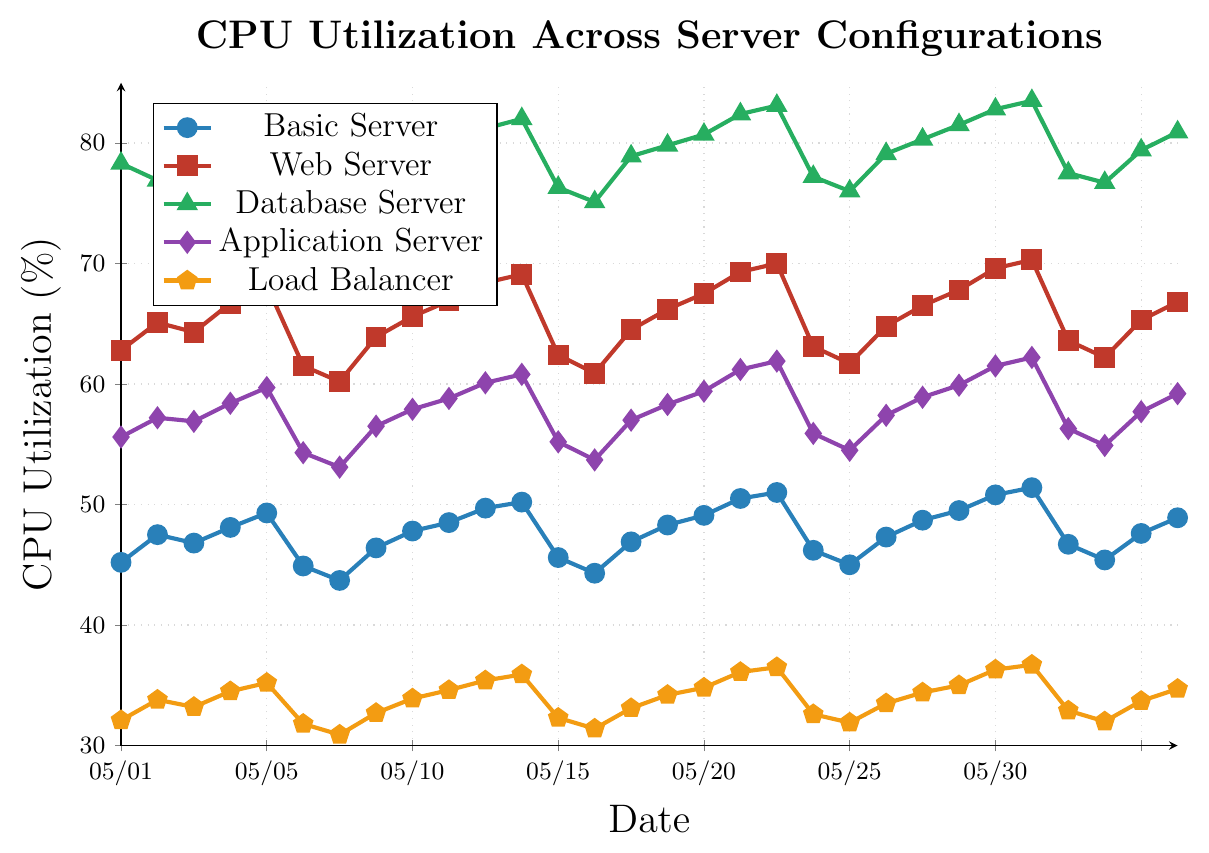How does the CPU utilization of the Web Server compare to the Basic Server on May 12? By examining the points corresponding to May 12 for both lines, we see the Web Server has a utilization of 69.1% and the Basic Server has a utilization of 50.2%. The Web Server's utilization is higher.
Answer: The Web Server's utilization is higher Which server configuration, Basic Server or Database Server, has a larger change in CPU utilization from May 1 to May 30? On May 1, the Basic Server is at 45.2% and on May 30, it is at 48.9%. For the Database Server, it is 78.3% on May 1 and 80.9% on May 30. Differences are calculated as follows: Basic Server: 48.9 - 45.2 = 3.7% and Database Server: 80.9 - 78.3 = 2.6%. So, the Basic Server exhibits a larger change.
Answer: Basic Server What is the average CPU utilization for the Load Balancer over the given period? Summing the Load Balancer's values for each day: 32.1 + 33.8 + ... + 34.7 = 1020.4. Dividing by the 30 days: 1020.4 / 30 ≈ 34.01%.
Answer: 34.01% Between May 15 and May 20, which server has the most stable CPU utilization? Stability can be determined by the smallest range of values; between May 15-20: 
- Basic Server ranges from 46.9% to 51.0% (4.1%)
- Web Server ranges from 64.5% to 70.0% (5.5%)
- Database Server ranges from 78.9% to 83.1% (4.2%)
- Application Server ranges from 57.0% to 61.9% (4.9%)
- Load Balancer ranges from 33.1% to 36.5% (3.4%)
The Load Balancer fluctuates the least.
Answer: Load Balancer On which dates does the Application Server have its peak CPU utilization, and what is the value? Looking at the peaks of the Application Server’s line, the highest point is on May 26, reading 62.2%.
Answer: May 26, 62.2% Is there a day when all server configurations experienced an increase in the CPU utilization compared to the previous day? By referencing the data day by day: May 4 is such a day. Compare May 3 and May 4: 
- Basic: 46.8% to 48.1%
- Web: 64.3% to 66.7%
- Database: 79.5% to 77.8%
- Application: 56.9% to 58.4%
- Load Balancer: 33.2% to 34.5%
Note: On May 4, Database Server actually decreases, so no such day exists across all configurations.
Answer: No Which server configuration has the lowest peak utilization throughout the period, and what is this peak value? Examining maxima for all:
- Basic Server: 51.4%
- Web Server: 70.3%
- Database Server: 83.5%
- Application Server: 62.2%
- Load Balancer: 36.7%
Load Balancer has the lowest peak: 36.7%.
Answer: Load Balancer, 36.7% Which server configuration saw the largest drop in CPU utilization on a single day, and what is the value of that drop? Evaluating differences:
- Basic Server: Largest drop is 49.3% to 44.9% = 4.4% (May 5 to May 6)
- Web Server: Largest drop is 68.2% to 61.5% = 6.7% (May 5 to May 6)
- Database Server: Largest drop is 80.1% to 75.6% = 4.5% (May 5 to May 6)
- Application Server: Largest drop is 59.7% to 54.3% = 5.4% (May 5 to May 6)
- Load Balancer: Largest drop is 35.2% to 31.8% = 3.4% (May 5 to May 6)
Web Server experiences the largest drop: 6.7%.
Answer: Web Server, 6.7% 